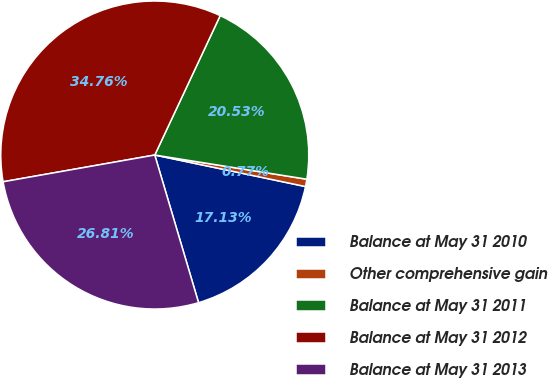Convert chart. <chart><loc_0><loc_0><loc_500><loc_500><pie_chart><fcel>Balance at May 31 2010<fcel>Other comprehensive gain<fcel>Balance at May 31 2011<fcel>Balance at May 31 2012<fcel>Balance at May 31 2013<nl><fcel>17.13%<fcel>0.77%<fcel>20.53%<fcel>34.76%<fcel>26.81%<nl></chart> 